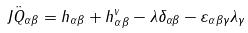Convert formula to latex. <formula><loc_0><loc_0><loc_500><loc_500>J \ddot { Q } _ { \alpha \beta } = h _ { \alpha \beta } + h _ { \alpha \beta } ^ { v } - \lambda \delta _ { \alpha \beta } - \varepsilon _ { \alpha \beta \gamma } \lambda _ { \gamma }</formula> 